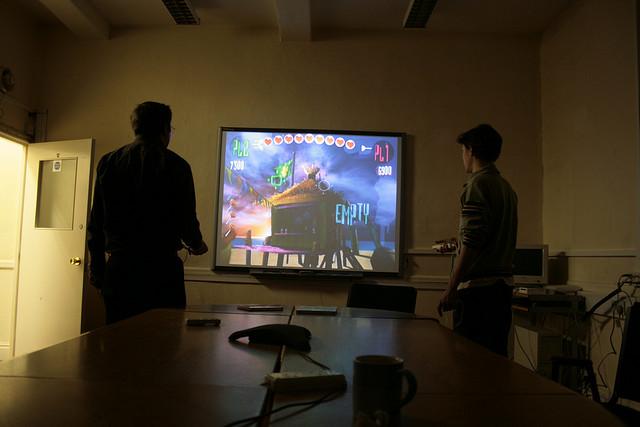What are they doing?
Short answer required. Playing. How many people are watching the TV?
Answer briefly. 2. What is this person using?
Concise answer only. Wii. What is on display on the TV?
Keep it brief. Video game. Where is the mug?
Be succinct. Table. Is the door closed?
Give a very brief answer. No. Is the viewer shown likely to be in the target demographic for the program being viewed?
Write a very short answer. Yes. 